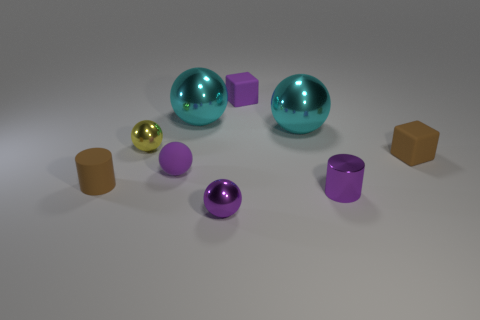Do the brown object that is right of the small brown rubber cylinder and the small yellow shiny thing have the same shape?
Make the answer very short. No. How many brown things are behind the small purple matte ball and on the left side of the brown matte block?
Ensure brevity in your answer.  0. What is the small yellow sphere made of?
Offer a terse response. Metal. Is there anything else that is the same color as the tiny rubber cylinder?
Your answer should be compact. Yes. Is the material of the tiny purple cube the same as the tiny brown cylinder?
Make the answer very short. Yes. How many metallic cylinders are to the left of the small brown matte thing that is to the right of the purple metallic thing behind the tiny purple shiny ball?
Your response must be concise. 1. How many large cyan things are there?
Your answer should be compact. 2. Is the number of brown things that are on the right side of the small purple rubber cube less than the number of big cyan spheres left of the yellow ball?
Offer a terse response. No. Are there fewer purple cubes behind the yellow metallic ball than small yellow metallic balls?
Offer a terse response. No. What is the tiny cylinder that is on the right side of the small metal sphere behind the small purple ball that is in front of the small brown cylinder made of?
Ensure brevity in your answer.  Metal. 